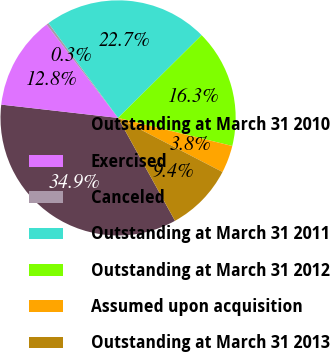Convert chart to OTSL. <chart><loc_0><loc_0><loc_500><loc_500><pie_chart><fcel>Outstanding at March 31 2010<fcel>Exercised<fcel>Canceled<fcel>Outstanding at March 31 2011<fcel>Outstanding at March 31 2012<fcel>Assumed upon acquisition<fcel>Outstanding at March 31 2013<nl><fcel>34.85%<fcel>12.8%<fcel>0.32%<fcel>22.65%<fcel>16.26%<fcel>3.77%<fcel>9.35%<nl></chart> 